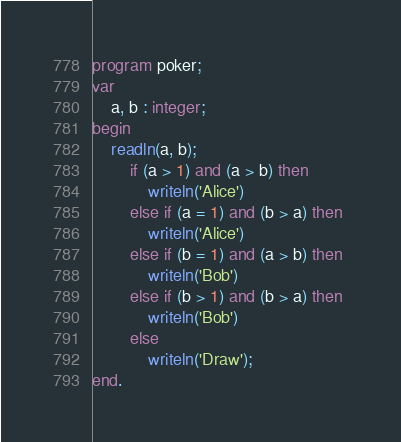Convert code to text. <code><loc_0><loc_0><loc_500><loc_500><_Pascal_>program poker;
var
	a, b : integer;
begin
	readln(a, b);
		if (a > 1) and (a > b) then
			writeln('Alice')
		else if (a = 1) and (b > a) then
			writeln('Alice')
		else if (b = 1) and (a > b) then
			writeln('Bob')
		else if (b > 1) and (b > a) then 
			writeln('Bob')
		else
			writeln('Draw');
end.</code> 